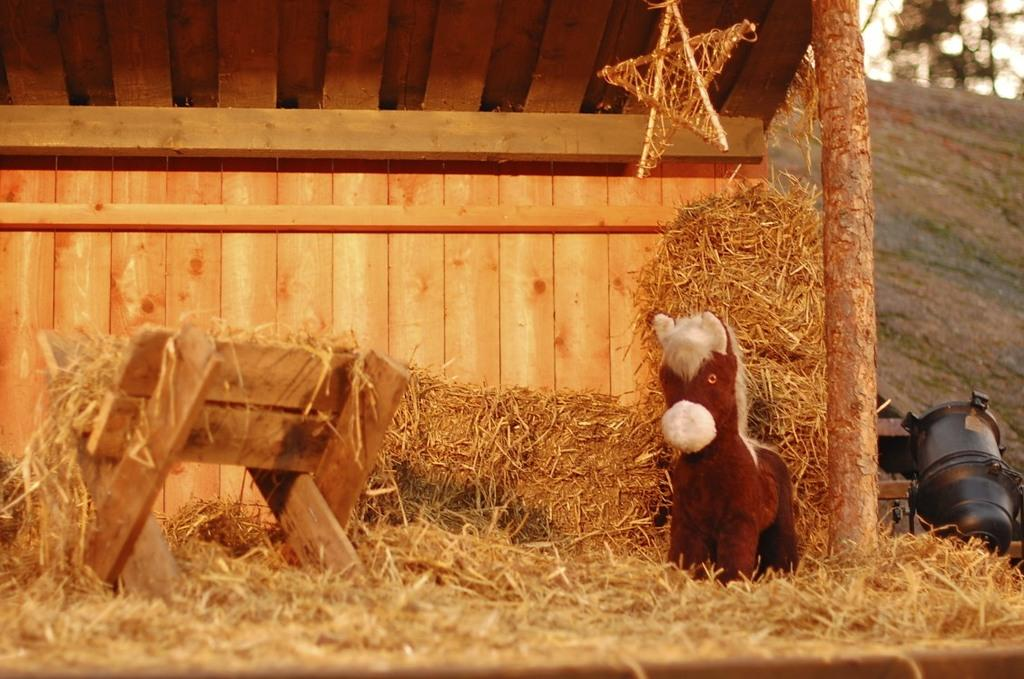What type of structure is visible in the image? There is a wooden shed in the image. What can be found inside the shed? There is grass, a stand, a toy, and a star inside the shed. What is the object on the ground outside the shed? There is an object on the ground that looks like a motor. What type of neck accessory is hanging from the star inside the shed? There is no neck accessory present in the image; the star is the only item mentioned inside the shed. 